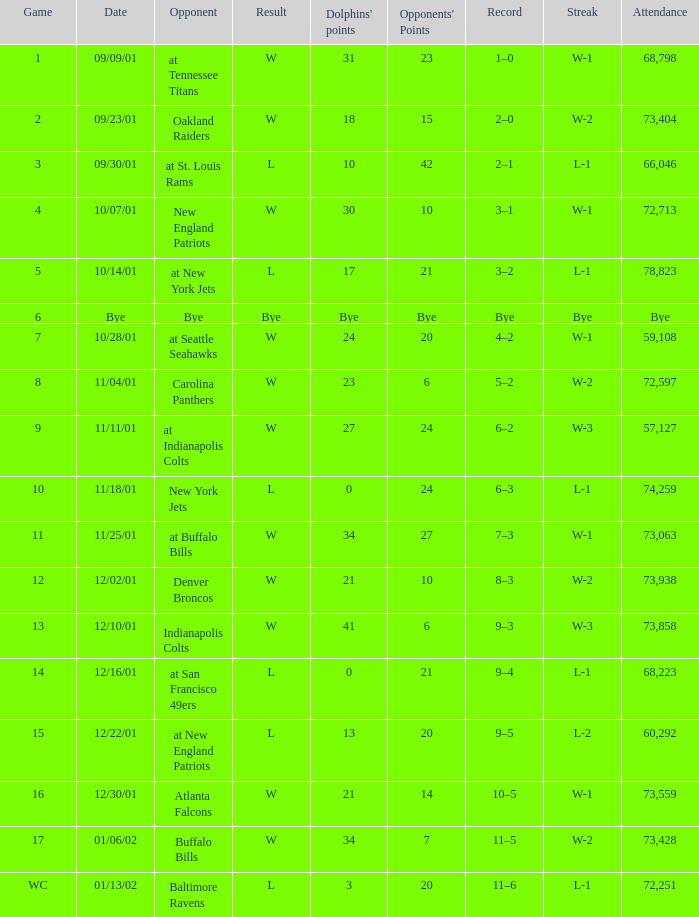How many opponents points were there on 11/11/01? 24.0. 